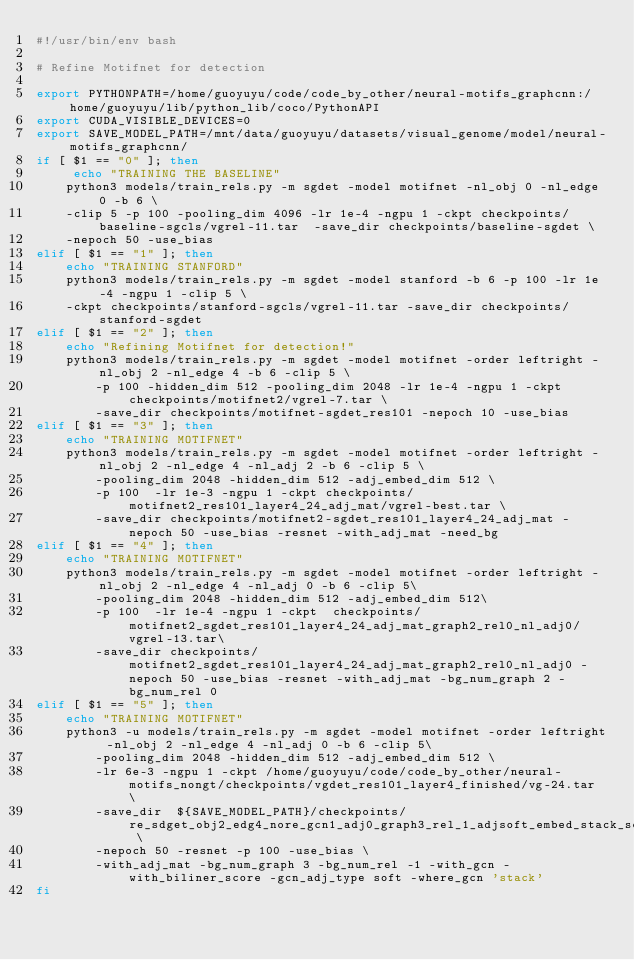<code> <loc_0><loc_0><loc_500><loc_500><_Bash_>#!/usr/bin/env bash

# Refine Motifnet for detection

export PYTHONPATH=/home/guoyuyu/code/code_by_other/neural-motifs_graphcnn:/home/guoyuyu/lib/python_lib/coco/PythonAPI
export CUDA_VISIBLE_DEVICES=0
export SAVE_MODEL_PATH=/mnt/data/guoyuyu/datasets/visual_genome/model/neural-motifs_graphcnn/
if [ $1 == "0" ]; then
     echo "TRAINING THE BASELINE"
    python3 models/train_rels.py -m sgdet -model motifnet -nl_obj 0 -nl_edge 0 -b 6 \
    -clip 5 -p 100 -pooling_dim 4096 -lr 1e-4 -ngpu 1 -ckpt checkpoints/baseline-sgcls/vgrel-11.tar  -save_dir checkpoints/baseline-sgdet \
    -nepoch 50 -use_bias
elif [ $1 == "1" ]; then
    echo "TRAINING STANFORD"
    python3 models/train_rels.py -m sgdet -model stanford -b 6 -p 100 -lr 1e-4 -ngpu 1 -clip 5 \
    -ckpt checkpoints/stanford-sgcls/vgrel-11.tar -save_dir checkpoints/stanford-sgdet
elif [ $1 == "2" ]; then
    echo "Refining Motifnet for detection!"
    python3 models/train_rels.py -m sgdet -model motifnet -order leftright -nl_obj 2 -nl_edge 4 -b 6 -clip 5 \
        -p 100 -hidden_dim 512 -pooling_dim 2048 -lr 1e-4 -ngpu 1 -ckpt checkpoints/motifnet2/vgrel-7.tar \
        -save_dir checkpoints/motifnet-sgdet_res101 -nepoch 10 -use_bias
elif [ $1 == "3" ]; then
    echo "TRAINING MOTIFNET"
    python3 models/train_rels.py -m sgdet -model motifnet -order leftright -nl_obj 2 -nl_edge 4 -nl_adj 2 -b 6 -clip 5 \
        -pooling_dim 2048 -hidden_dim 512 -adj_embed_dim 512 \
        -p 100  -lr 1e-3 -ngpu 1 -ckpt checkpoints/motifnet2_res101_layer4_24_adj_mat/vgrel-best.tar \
        -save_dir checkpoints/motifnet2-sgdet_res101_layer4_24_adj_mat -nepoch 50 -use_bias -resnet -with_adj_mat -need_bg
elif [ $1 == "4" ]; then
    echo "TRAINING MOTIFNET"
    python3 models/train_rels.py -m sgdet -model motifnet -order leftright -nl_obj 2 -nl_edge 4 -nl_adj 0 -b 6 -clip 5\
        -pooling_dim 2048 -hidden_dim 512 -adj_embed_dim 512\
        -p 100  -lr 1e-4 -ngpu 1 -ckpt  checkpoints/motifnet2_sgdet_res101_layer4_24_adj_mat_graph2_rel0_nl_adj0/vgrel-13.tar\
        -save_dir checkpoints/motifnet2_sgdet_res101_layer4_24_adj_mat_graph2_rel0_nl_adj0 -nepoch 50 -use_bias -resnet -with_adj_mat -bg_num_graph 2 -bg_num_rel 0
elif [ $1 == "5" ]; then
    echo "TRAINING MOTIFNET"
    python3 -u models/train_rels.py -m sgdet -model motifnet -order leftright -nl_obj 2 -nl_edge 4 -nl_adj 0 -b 6 -clip 5\
        -pooling_dim 2048 -hidden_dim 512 -adj_embed_dim 512 \
        -lr 6e-3 -ngpu 1 -ckpt /home/guoyuyu/code/code_by_other/neural-motifs_nongt/checkpoints/vgdet_res101_layer4_finished/vg-24.tar \
        -save_dir  ${SAVE_MODEL_PATH}/checkpoints/re_sdget_obj2_edg4_nore_gcn1_adj0_graph3_rel_1_adjsoft_embed_stack_softadjmat_nopassedggcnembed_lr6e3 \
        -nepoch 50 -resnet -p 100 -use_bias \
        -with_adj_mat -bg_num_graph 3 -bg_num_rel -1 -with_gcn -with_biliner_score -gcn_adj_type soft -where_gcn 'stack'
fi
</code> 